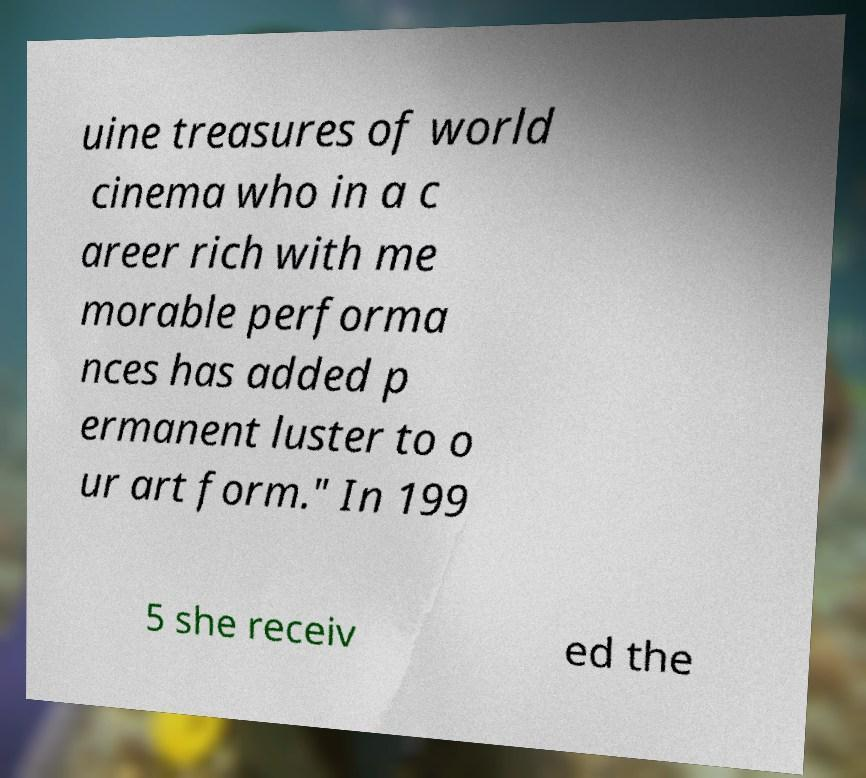I need the written content from this picture converted into text. Can you do that? uine treasures of world cinema who in a c areer rich with me morable performa nces has added p ermanent luster to o ur art form." In 199 5 she receiv ed the 